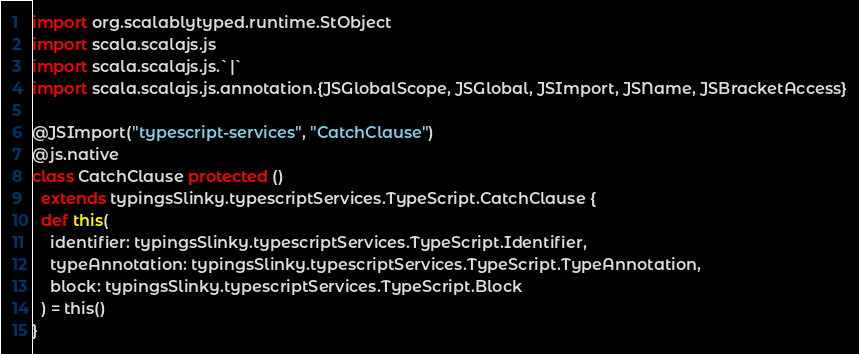Convert code to text. <code><loc_0><loc_0><loc_500><loc_500><_Scala_>
import org.scalablytyped.runtime.StObject
import scala.scalajs.js
import scala.scalajs.js.`|`
import scala.scalajs.js.annotation.{JSGlobalScope, JSGlobal, JSImport, JSName, JSBracketAccess}

@JSImport("typescript-services", "CatchClause")
@js.native
class CatchClause protected ()
  extends typingsSlinky.typescriptServices.TypeScript.CatchClause {
  def this(
    identifier: typingsSlinky.typescriptServices.TypeScript.Identifier,
    typeAnnotation: typingsSlinky.typescriptServices.TypeScript.TypeAnnotation,
    block: typingsSlinky.typescriptServices.TypeScript.Block
  ) = this()
}
</code> 